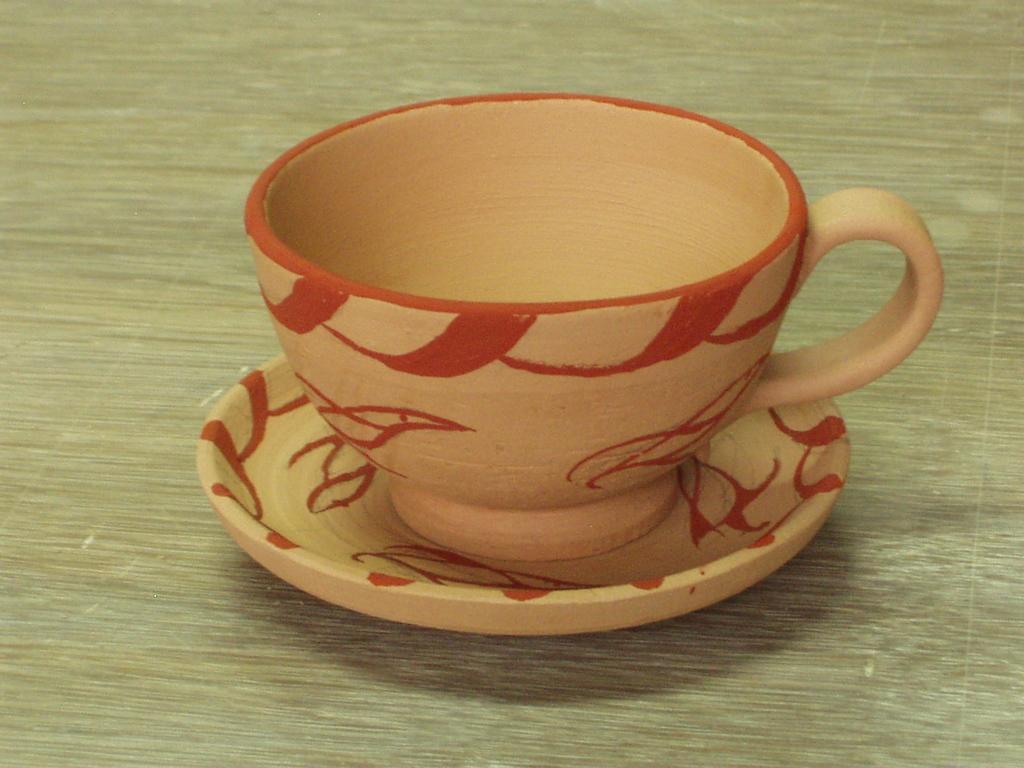Could you give a brief overview of what you see in this image? In the picture we can see a cup and a saucer on it we can see some designs. 